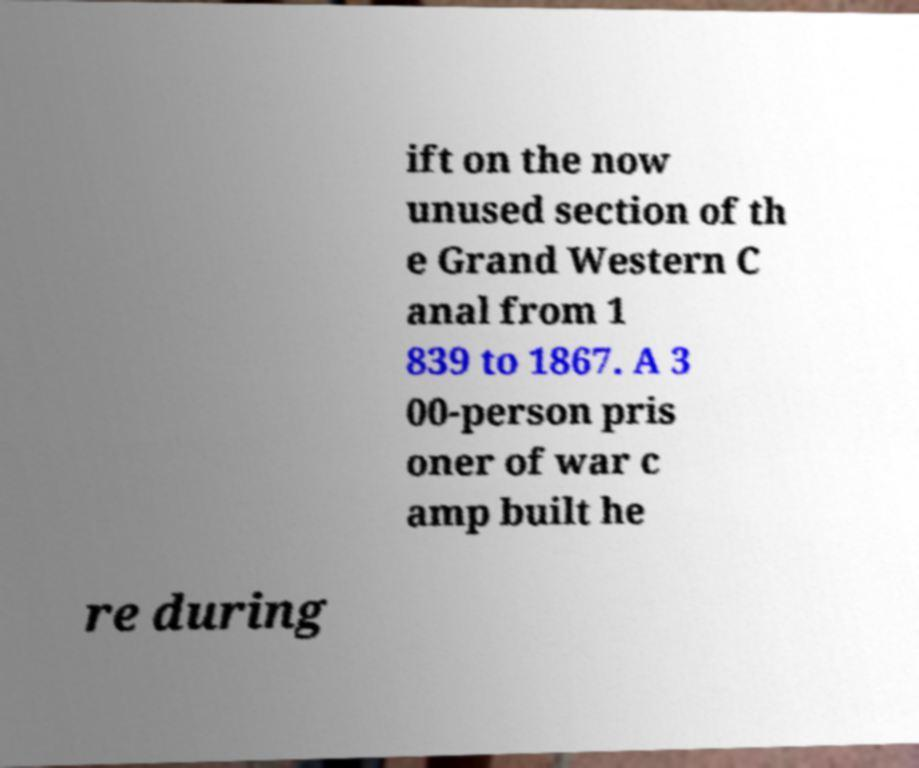There's text embedded in this image that I need extracted. Can you transcribe it verbatim? ift on the now unused section of th e Grand Western C anal from 1 839 to 1867. A 3 00-person pris oner of war c amp built he re during 